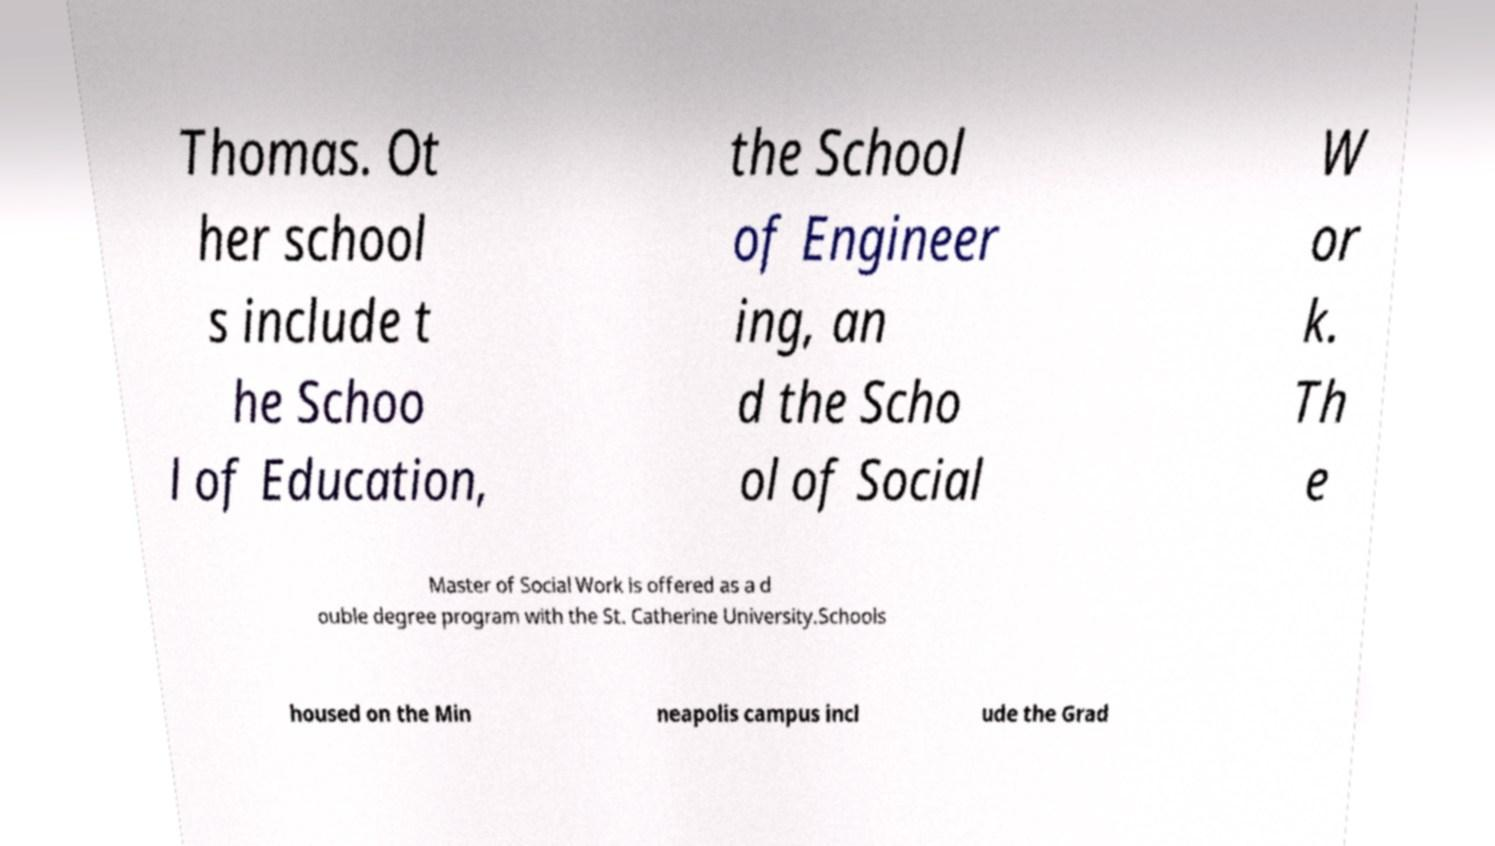What messages or text are displayed in this image? I need them in a readable, typed format. Thomas. Ot her school s include t he Schoo l of Education, the School of Engineer ing, an d the Scho ol of Social W or k. Th e Master of Social Work is offered as a d ouble degree program with the St. Catherine University.Schools housed on the Min neapolis campus incl ude the Grad 